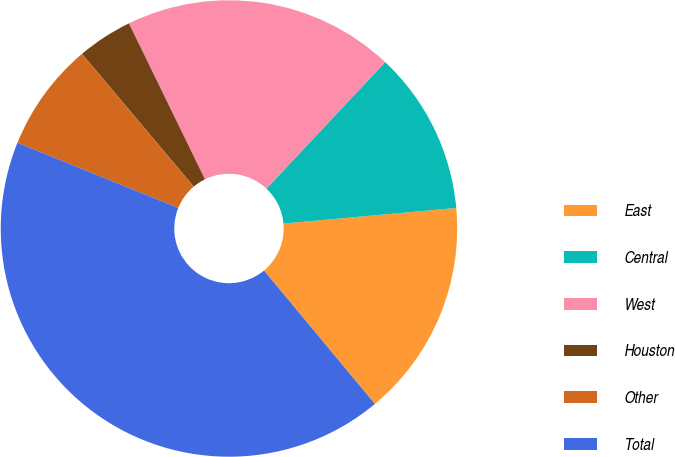<chart> <loc_0><loc_0><loc_500><loc_500><pie_chart><fcel>East<fcel>Central<fcel>West<fcel>Houston<fcel>Other<fcel>Total<nl><fcel>15.39%<fcel>11.57%<fcel>19.22%<fcel>3.91%<fcel>7.74%<fcel>42.17%<nl></chart> 